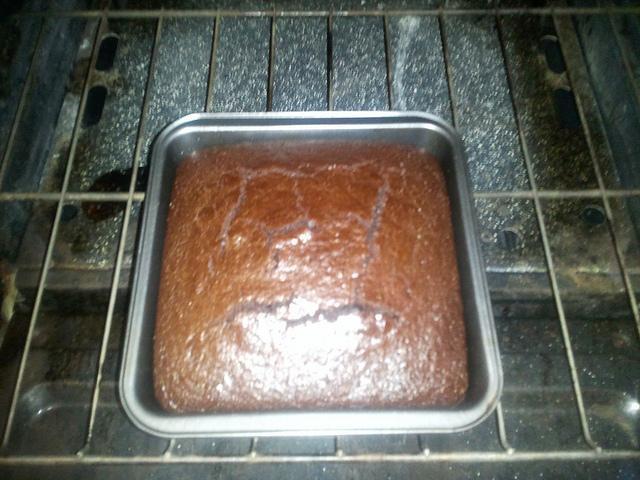How many bottles of wine are there?
Give a very brief answer. 0. 